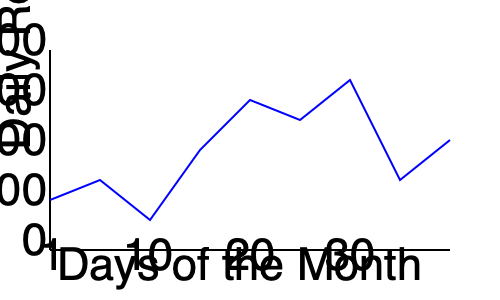Based on the line graph showing the diner's daily revenue over a month, which day had the highest revenue, and what was the approximate amount? To answer this question, we need to follow these steps:

1. Examine the y-axis (vertical axis) to understand the revenue scale:
   - The y-axis represents daily revenue in dollars.
   - The scale goes from $0 to $2000 in increments of $500.

2. Look at the x-axis (horizontal axis) to understand the time scale:
   - The x-axis represents days of the month.
   - It's labeled from 1 to 30, with markers at 1, 10, 20, and 30.

3. Identify the highest point on the graph:
   - The blue line represents the daily revenue.
   - The highest point appears to be around the 25th day of the month.

4. Estimate the revenue for the highest point:
   - The peak of the line is slightly below the $2000 mark.
   - It's approximately at the $1900 level.

5. Double-check that no other points are higher:
   - Scanning the entire graph confirms that this is indeed the highest point.

Therefore, the day with the highest revenue was around the 25th day of the month, with an approximate revenue of $1900.
Answer: Day 25, approximately $1900 